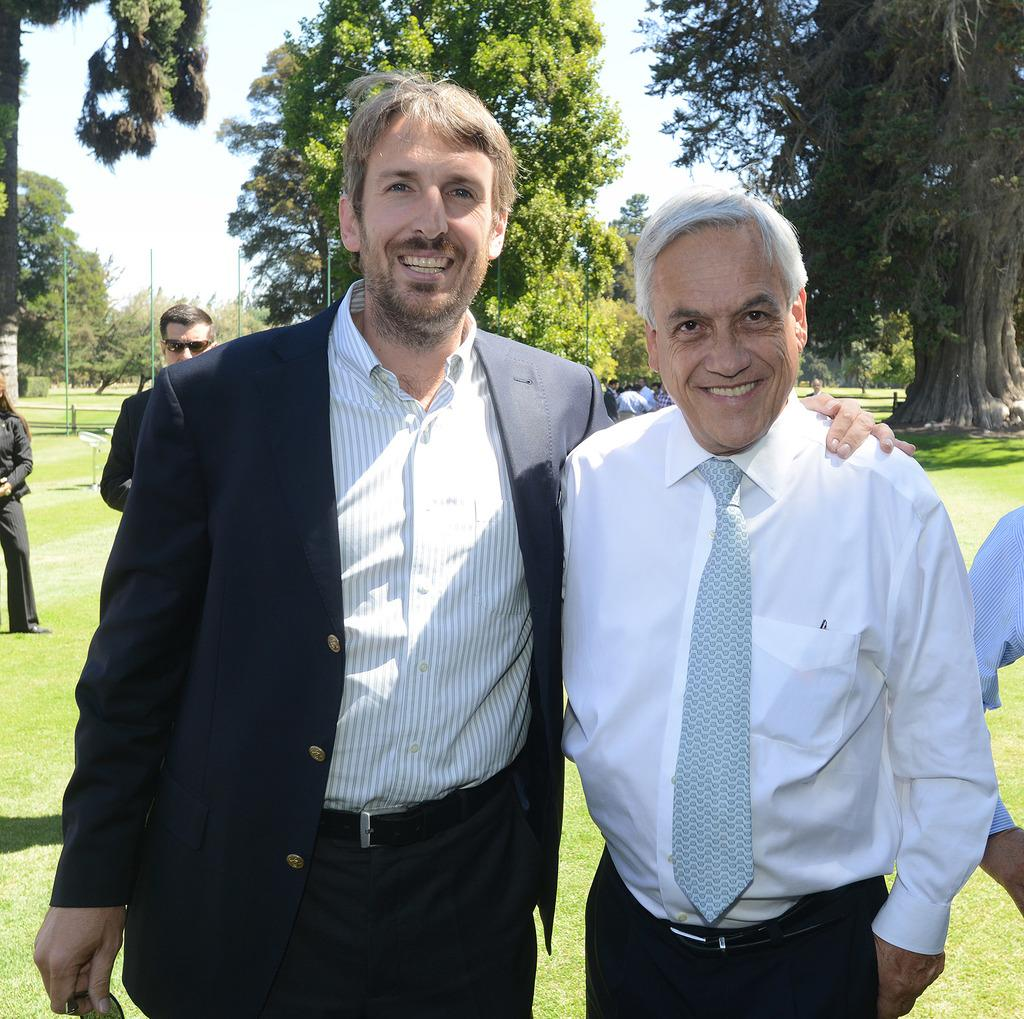How many people are in the image? There is a group of people in the image. Where are the people standing? The people are standing on the grass. What can be seen in the background of the image? There are trees and poles in the background of the image. What shape is the home that the people are standing in front of in the image? There is no home present in the image; the people are standing on the grass with trees and poles in the background. 